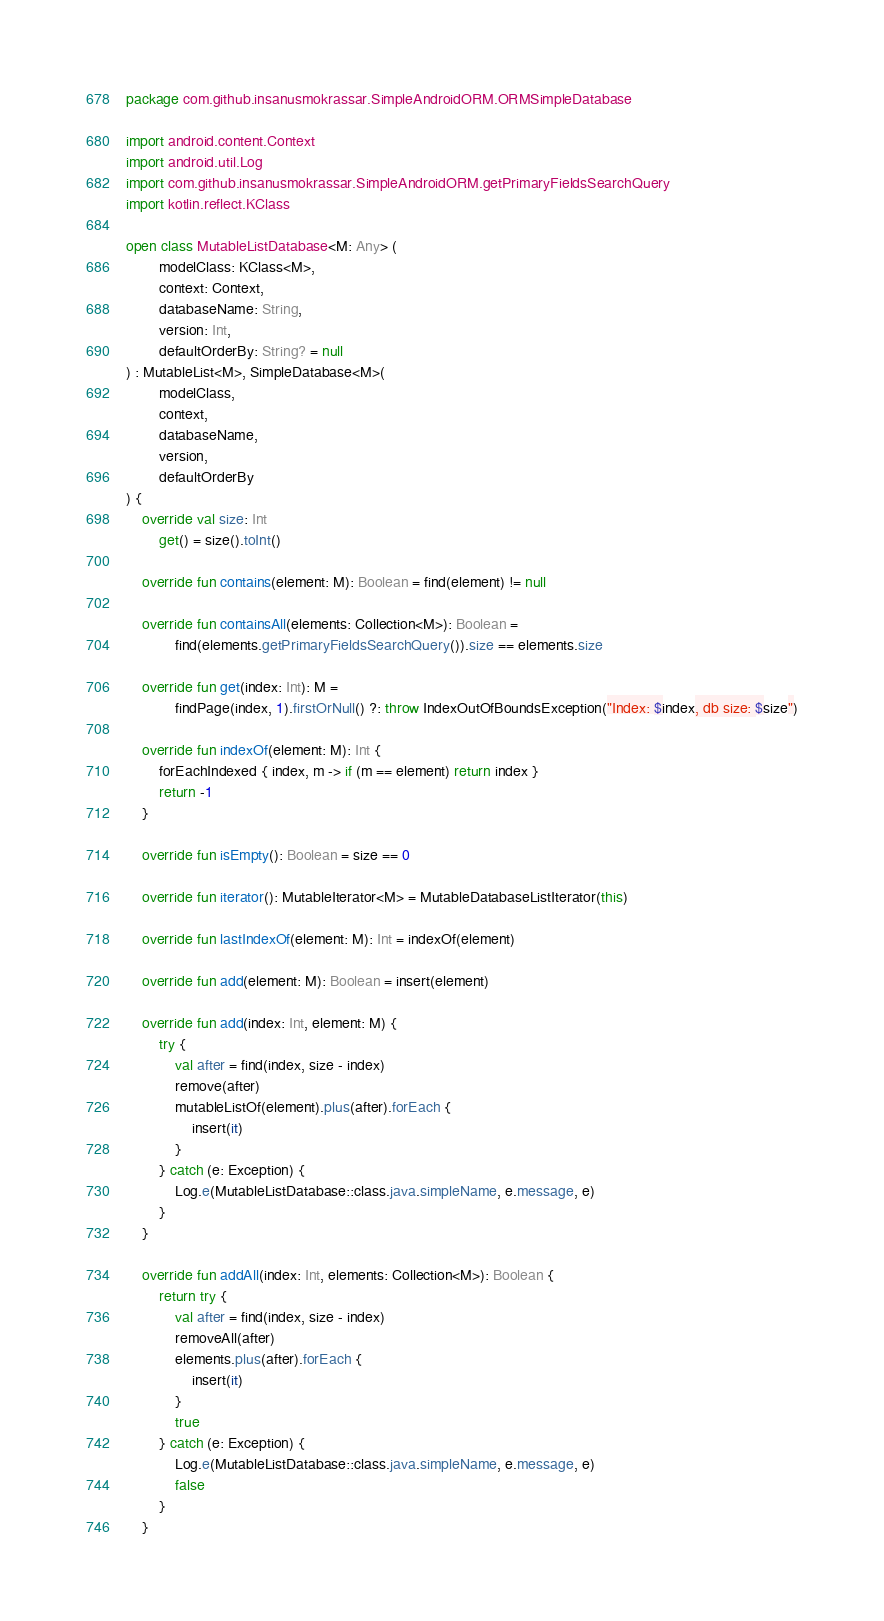Convert code to text. <code><loc_0><loc_0><loc_500><loc_500><_Kotlin_>package com.github.insanusmokrassar.SimpleAndroidORM.ORMSimpleDatabase

import android.content.Context
import android.util.Log
import com.github.insanusmokrassar.SimpleAndroidORM.getPrimaryFieldsSearchQuery
import kotlin.reflect.KClass

open class MutableListDatabase<M: Any> (
        modelClass: KClass<M>,
        context: Context,
        databaseName: String,
        version: Int,
        defaultOrderBy: String? = null
) : MutableList<M>, SimpleDatabase<M>(
        modelClass,
        context,
        databaseName,
        version,
        defaultOrderBy
) {
    override val size: Int
        get() = size().toInt()

    override fun contains(element: M): Boolean = find(element) != null

    override fun containsAll(elements: Collection<M>): Boolean =
            find(elements.getPrimaryFieldsSearchQuery()).size == elements.size

    override fun get(index: Int): M =
            findPage(index, 1).firstOrNull() ?: throw IndexOutOfBoundsException("Index: $index, db size: $size")

    override fun indexOf(element: M): Int {
        forEachIndexed { index, m -> if (m == element) return index }
        return -1
    }

    override fun isEmpty(): Boolean = size == 0

    override fun iterator(): MutableIterator<M> = MutableDatabaseListIterator(this)

    override fun lastIndexOf(element: M): Int = indexOf(element)

    override fun add(element: M): Boolean = insert(element)

    override fun add(index: Int, element: M) {
        try {
            val after = find(index, size - index)
            remove(after)
            mutableListOf(element).plus(after).forEach {
                insert(it)
            }
        } catch (e: Exception) {
            Log.e(MutableListDatabase::class.java.simpleName, e.message, e)
        }
    }

    override fun addAll(index: Int, elements: Collection<M>): Boolean {
        return try {
            val after = find(index, size - index)
            removeAll(after)
            elements.plus(after).forEach {
                insert(it)
            }
            true
        } catch (e: Exception) {
            Log.e(MutableListDatabase::class.java.simpleName, e.message, e)
            false
        }
    }
</code> 